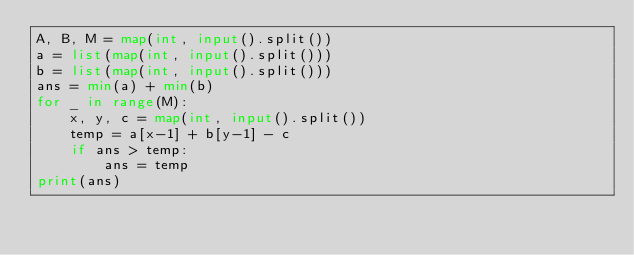Convert code to text. <code><loc_0><loc_0><loc_500><loc_500><_Python_>A, B, M = map(int, input().split())
a = list(map(int, input().split()))
b = list(map(int, input().split()))
ans = min(a) + min(b)
for _ in range(M):
    x, y, c = map(int, input().split())
    temp = a[x-1] + b[y-1] - c
    if ans > temp:
        ans = temp
print(ans)</code> 